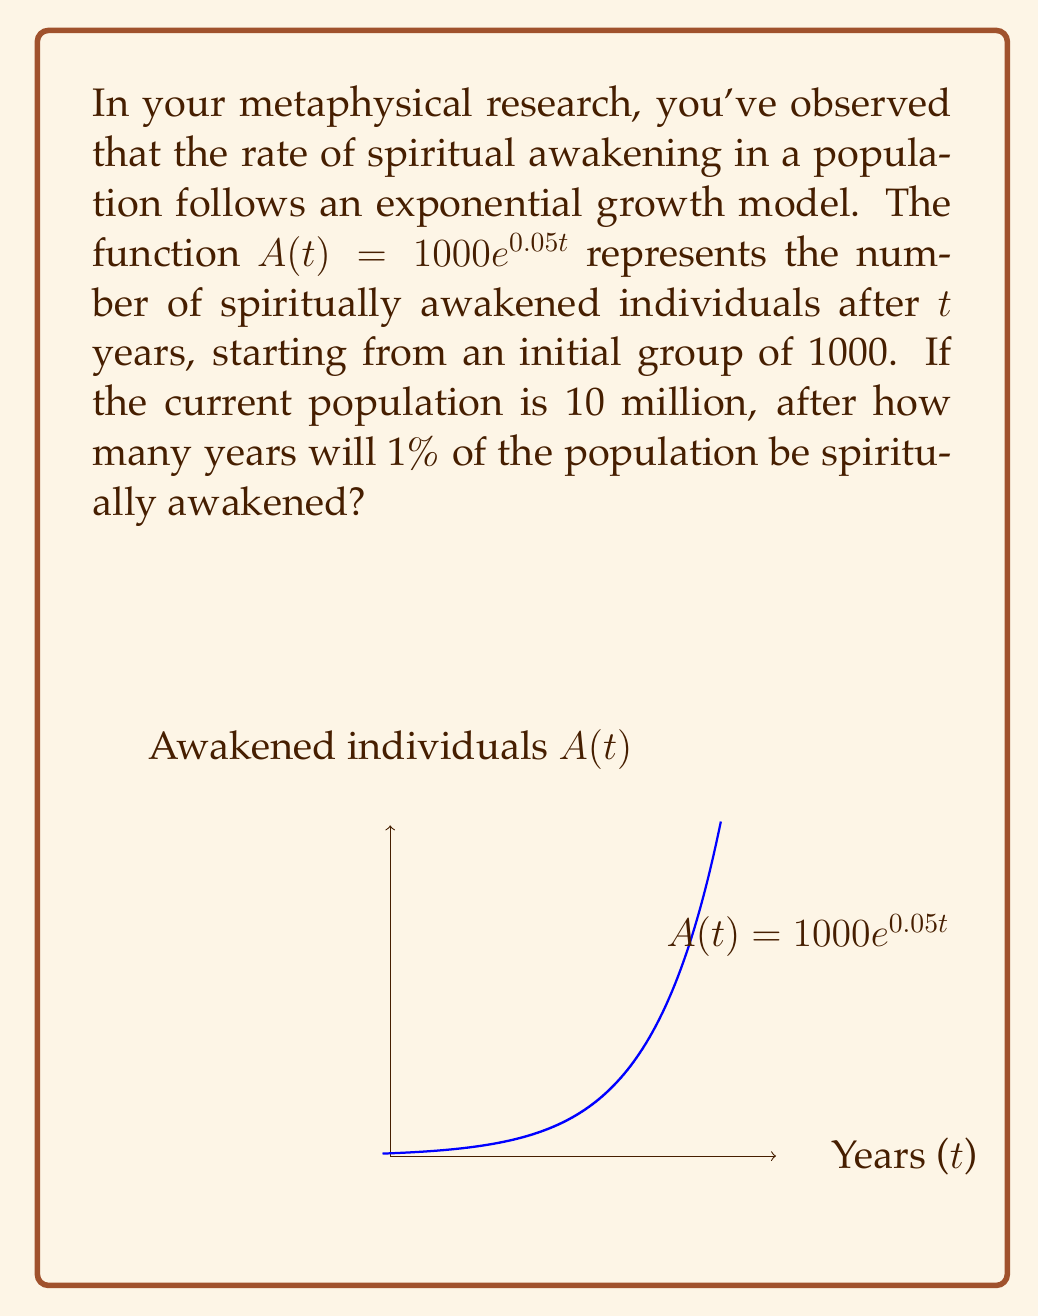Help me with this question. Let's approach this step-by-step:

1) We need to find $t$ when $A(t)$ equals 1% of the population:
   $A(t) = 0.01 \times 10,000,000 = 100,000$

2) Now we can set up the equation:
   $100,000 = 1000e^{0.05t}$

3) Divide both sides by 1000:
   $100 = e^{0.05t}$

4) Take the natural logarithm of both sides:
   $\ln(100) = \ln(e^{0.05t})$

5) Simplify the right side using the properties of logarithms:
   $\ln(100) = 0.05t$

6) Calculate $\ln(100)$:
   $4.60517 = 0.05t$

7) Divide both sides by 0.05:
   $t = 4.60517 / 0.05 = 92.1034$

Therefore, it will take approximately 92.1034 years for 1% of the population to be spiritually awakened.
Answer: 92.1034 years 